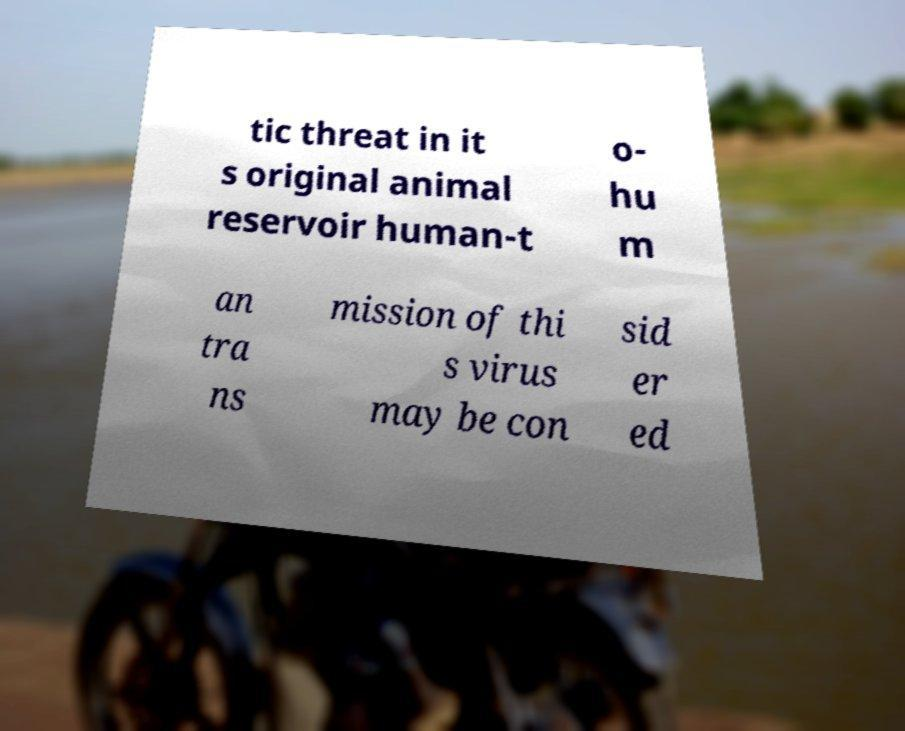Could you assist in decoding the text presented in this image and type it out clearly? tic threat in it s original animal reservoir human-t o- hu m an tra ns mission of thi s virus may be con sid er ed 